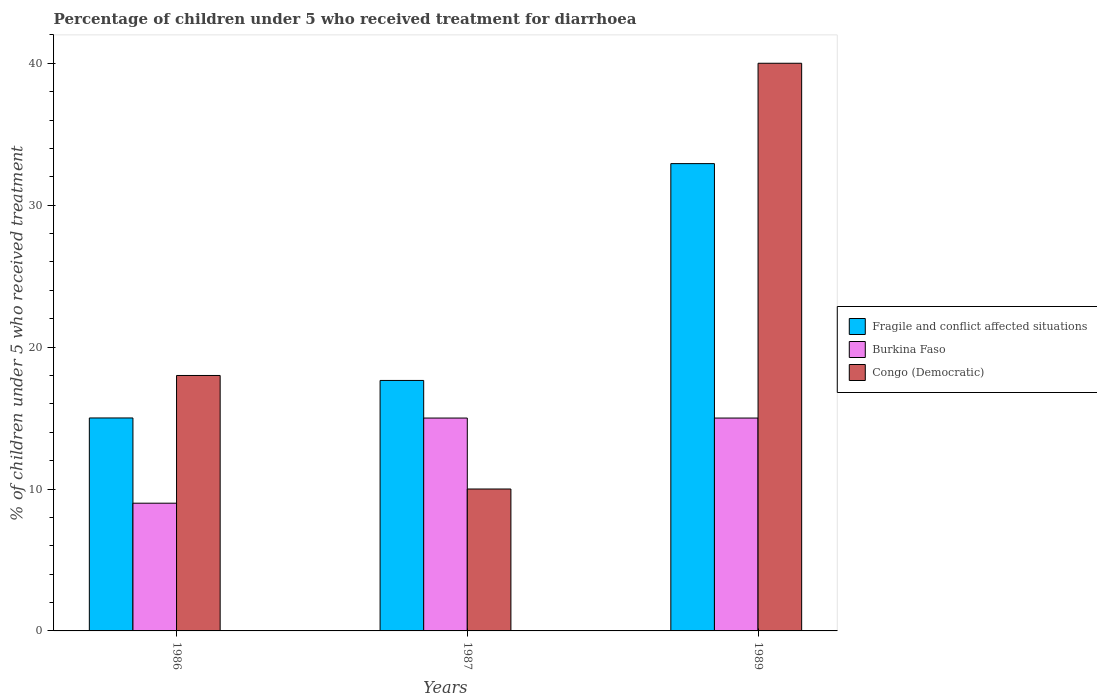How many bars are there on the 3rd tick from the left?
Give a very brief answer. 3. How many bars are there on the 3rd tick from the right?
Your response must be concise. 3. What is the label of the 3rd group of bars from the left?
Give a very brief answer. 1989. What is the percentage of children who received treatment for diarrhoea  in Burkina Faso in 1989?
Your response must be concise. 15. Across all years, what is the maximum percentage of children who received treatment for diarrhoea  in Burkina Faso?
Your answer should be very brief. 15. In which year was the percentage of children who received treatment for diarrhoea  in Congo (Democratic) minimum?
Offer a very short reply. 1987. What is the difference between the percentage of children who received treatment for diarrhoea  in Congo (Democratic) in 1986 and the percentage of children who received treatment for diarrhoea  in Burkina Faso in 1989?
Ensure brevity in your answer.  3. What is the average percentage of children who received treatment for diarrhoea  in Fragile and conflict affected situations per year?
Provide a short and direct response. 21.86. In the year 1987, what is the difference between the percentage of children who received treatment for diarrhoea  in Congo (Democratic) and percentage of children who received treatment for diarrhoea  in Fragile and conflict affected situations?
Your response must be concise. -7.65. What is the ratio of the percentage of children who received treatment for diarrhoea  in Congo (Democratic) in 1987 to that in 1989?
Make the answer very short. 0.25. What is the difference between the highest and the second highest percentage of children who received treatment for diarrhoea  in Burkina Faso?
Provide a succinct answer. 0. Is the sum of the percentage of children who received treatment for diarrhoea  in Burkina Faso in 1986 and 1987 greater than the maximum percentage of children who received treatment for diarrhoea  in Fragile and conflict affected situations across all years?
Your answer should be very brief. No. What does the 1st bar from the left in 1986 represents?
Give a very brief answer. Fragile and conflict affected situations. What does the 1st bar from the right in 1986 represents?
Your answer should be very brief. Congo (Democratic). Is it the case that in every year, the sum of the percentage of children who received treatment for diarrhoea  in Congo (Democratic) and percentage of children who received treatment for diarrhoea  in Fragile and conflict affected situations is greater than the percentage of children who received treatment for diarrhoea  in Burkina Faso?
Your answer should be very brief. Yes. Are all the bars in the graph horizontal?
Ensure brevity in your answer.  No. Are the values on the major ticks of Y-axis written in scientific E-notation?
Offer a terse response. No. Where does the legend appear in the graph?
Your answer should be very brief. Center right. How many legend labels are there?
Keep it short and to the point. 3. What is the title of the graph?
Ensure brevity in your answer.  Percentage of children under 5 who received treatment for diarrhoea. What is the label or title of the X-axis?
Offer a terse response. Years. What is the label or title of the Y-axis?
Your answer should be compact. % of children under 5 who received treatment. What is the % of children under 5 who received treatment in Fragile and conflict affected situations in 1986?
Provide a succinct answer. 15.01. What is the % of children under 5 who received treatment in Fragile and conflict affected situations in 1987?
Provide a short and direct response. 17.65. What is the % of children under 5 who received treatment in Fragile and conflict affected situations in 1989?
Make the answer very short. 32.93. What is the % of children under 5 who received treatment in Burkina Faso in 1989?
Offer a very short reply. 15. What is the % of children under 5 who received treatment of Congo (Democratic) in 1989?
Offer a very short reply. 40. Across all years, what is the maximum % of children under 5 who received treatment of Fragile and conflict affected situations?
Offer a very short reply. 32.93. Across all years, what is the maximum % of children under 5 who received treatment of Burkina Faso?
Make the answer very short. 15. Across all years, what is the minimum % of children under 5 who received treatment in Fragile and conflict affected situations?
Provide a succinct answer. 15.01. Across all years, what is the minimum % of children under 5 who received treatment of Burkina Faso?
Your response must be concise. 9. What is the total % of children under 5 who received treatment of Fragile and conflict affected situations in the graph?
Your answer should be compact. 65.58. What is the total % of children under 5 who received treatment in Congo (Democratic) in the graph?
Make the answer very short. 68. What is the difference between the % of children under 5 who received treatment in Fragile and conflict affected situations in 1986 and that in 1987?
Provide a short and direct response. -2.64. What is the difference between the % of children under 5 who received treatment of Burkina Faso in 1986 and that in 1987?
Your answer should be very brief. -6. What is the difference between the % of children under 5 who received treatment of Congo (Democratic) in 1986 and that in 1987?
Give a very brief answer. 8. What is the difference between the % of children under 5 who received treatment in Fragile and conflict affected situations in 1986 and that in 1989?
Ensure brevity in your answer.  -17.92. What is the difference between the % of children under 5 who received treatment of Fragile and conflict affected situations in 1987 and that in 1989?
Your answer should be compact. -15.28. What is the difference between the % of children under 5 who received treatment in Congo (Democratic) in 1987 and that in 1989?
Ensure brevity in your answer.  -30. What is the difference between the % of children under 5 who received treatment of Fragile and conflict affected situations in 1986 and the % of children under 5 who received treatment of Burkina Faso in 1987?
Offer a terse response. 0.01. What is the difference between the % of children under 5 who received treatment of Fragile and conflict affected situations in 1986 and the % of children under 5 who received treatment of Congo (Democratic) in 1987?
Offer a very short reply. 5.01. What is the difference between the % of children under 5 who received treatment in Burkina Faso in 1986 and the % of children under 5 who received treatment in Congo (Democratic) in 1987?
Keep it short and to the point. -1. What is the difference between the % of children under 5 who received treatment of Fragile and conflict affected situations in 1986 and the % of children under 5 who received treatment of Burkina Faso in 1989?
Your answer should be very brief. 0.01. What is the difference between the % of children under 5 who received treatment in Fragile and conflict affected situations in 1986 and the % of children under 5 who received treatment in Congo (Democratic) in 1989?
Provide a succinct answer. -24.99. What is the difference between the % of children under 5 who received treatment of Burkina Faso in 1986 and the % of children under 5 who received treatment of Congo (Democratic) in 1989?
Give a very brief answer. -31. What is the difference between the % of children under 5 who received treatment of Fragile and conflict affected situations in 1987 and the % of children under 5 who received treatment of Burkina Faso in 1989?
Provide a succinct answer. 2.65. What is the difference between the % of children under 5 who received treatment in Fragile and conflict affected situations in 1987 and the % of children under 5 who received treatment in Congo (Democratic) in 1989?
Provide a short and direct response. -22.35. What is the average % of children under 5 who received treatment in Fragile and conflict affected situations per year?
Provide a short and direct response. 21.86. What is the average % of children under 5 who received treatment of Burkina Faso per year?
Offer a terse response. 13. What is the average % of children under 5 who received treatment of Congo (Democratic) per year?
Ensure brevity in your answer.  22.67. In the year 1986, what is the difference between the % of children under 5 who received treatment in Fragile and conflict affected situations and % of children under 5 who received treatment in Burkina Faso?
Provide a succinct answer. 6.01. In the year 1986, what is the difference between the % of children under 5 who received treatment of Fragile and conflict affected situations and % of children under 5 who received treatment of Congo (Democratic)?
Offer a terse response. -2.99. In the year 1987, what is the difference between the % of children under 5 who received treatment of Fragile and conflict affected situations and % of children under 5 who received treatment of Burkina Faso?
Offer a very short reply. 2.65. In the year 1987, what is the difference between the % of children under 5 who received treatment of Fragile and conflict affected situations and % of children under 5 who received treatment of Congo (Democratic)?
Provide a succinct answer. 7.65. In the year 1989, what is the difference between the % of children under 5 who received treatment in Fragile and conflict affected situations and % of children under 5 who received treatment in Burkina Faso?
Offer a very short reply. 17.93. In the year 1989, what is the difference between the % of children under 5 who received treatment of Fragile and conflict affected situations and % of children under 5 who received treatment of Congo (Democratic)?
Ensure brevity in your answer.  -7.07. What is the ratio of the % of children under 5 who received treatment in Fragile and conflict affected situations in 1986 to that in 1987?
Your response must be concise. 0.85. What is the ratio of the % of children under 5 who received treatment of Burkina Faso in 1986 to that in 1987?
Offer a very short reply. 0.6. What is the ratio of the % of children under 5 who received treatment in Congo (Democratic) in 1986 to that in 1987?
Provide a succinct answer. 1.8. What is the ratio of the % of children under 5 who received treatment in Fragile and conflict affected situations in 1986 to that in 1989?
Provide a short and direct response. 0.46. What is the ratio of the % of children under 5 who received treatment in Burkina Faso in 1986 to that in 1989?
Your answer should be very brief. 0.6. What is the ratio of the % of children under 5 who received treatment of Congo (Democratic) in 1986 to that in 1989?
Offer a terse response. 0.45. What is the ratio of the % of children under 5 who received treatment of Fragile and conflict affected situations in 1987 to that in 1989?
Give a very brief answer. 0.54. What is the ratio of the % of children under 5 who received treatment of Burkina Faso in 1987 to that in 1989?
Provide a succinct answer. 1. What is the difference between the highest and the second highest % of children under 5 who received treatment in Fragile and conflict affected situations?
Ensure brevity in your answer.  15.28. What is the difference between the highest and the second highest % of children under 5 who received treatment of Burkina Faso?
Provide a succinct answer. 0. What is the difference between the highest and the second highest % of children under 5 who received treatment of Congo (Democratic)?
Give a very brief answer. 22. What is the difference between the highest and the lowest % of children under 5 who received treatment in Fragile and conflict affected situations?
Offer a terse response. 17.92. What is the difference between the highest and the lowest % of children under 5 who received treatment of Burkina Faso?
Keep it short and to the point. 6. 